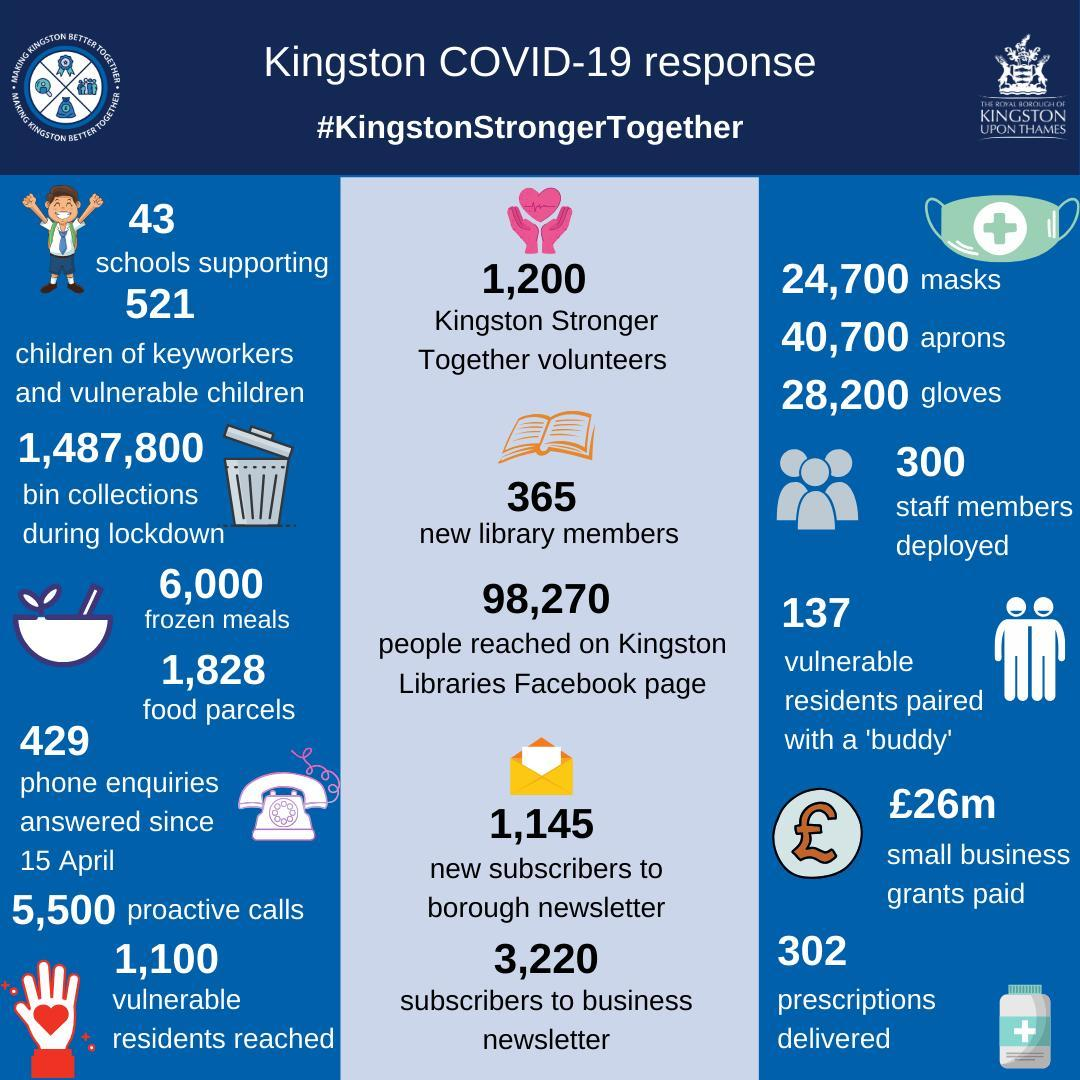How many staff members were deployed?
Answer the question with a short phrase. 300 How many frozen meals were provided? 6000 How many vulnerable residents were paired with a buddy? 137 How many phone enquiries were answered since 15 April? 429 How many new subscriptions where there to the borough newsletter? 1,145 How many prescriptions were delivered? 302 How many food parcels were delivered? 1,828 What was the total grants paid to small businesses (£m)? 26 How many new library members are there? 365 How many people reached on Kingston libraries Facebook page? 98,270 How many subscribers are there to the business newsletter? 3,220 How many proactive calls were made? 5,500 How many bin collections were made during lockdown? 1,487,800 How many Kingston Stronger Together volunteers are there? 1,200 